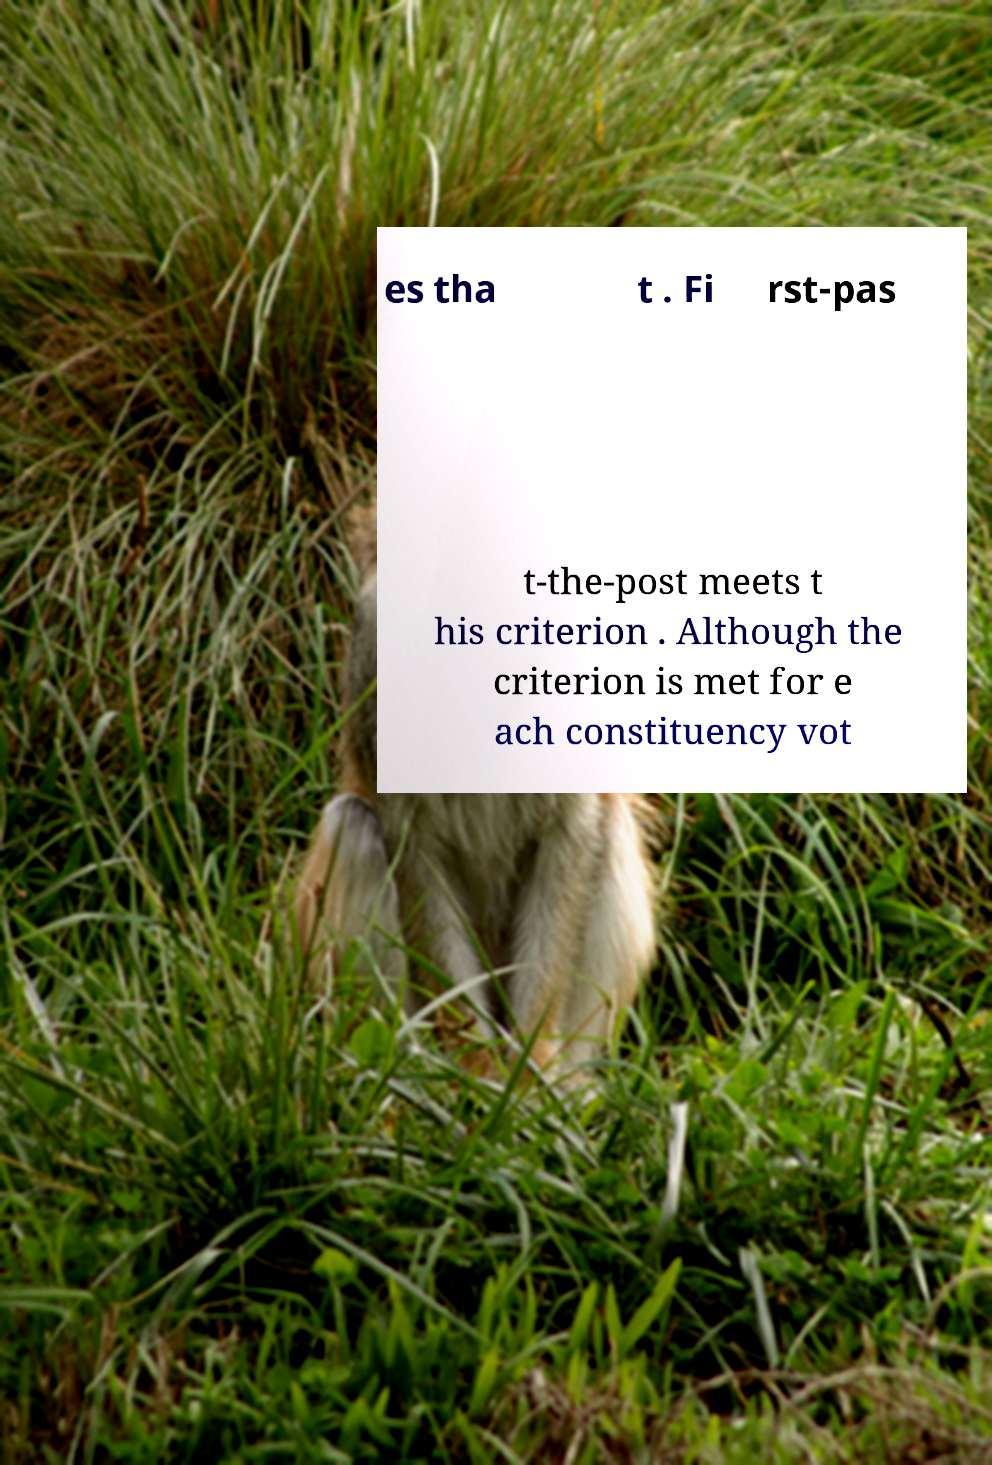Could you assist in decoding the text presented in this image and type it out clearly? es tha t . Fi rst-pas t-the-post meets t his criterion . Although the criterion is met for e ach constituency vot 